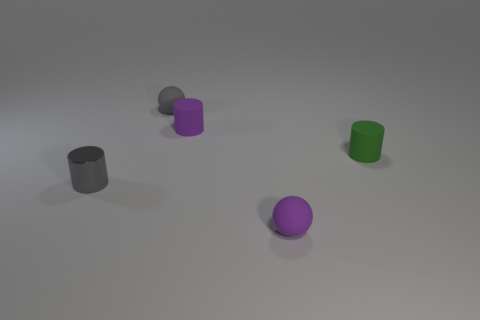Subtract 1 cylinders. How many cylinders are left? 2 Add 4 big yellow shiny cylinders. How many objects exist? 9 Subtract all cylinders. How many objects are left? 2 Add 2 green matte objects. How many green matte objects are left? 3 Add 4 small red objects. How many small red objects exist? 4 Subtract 0 yellow cubes. How many objects are left? 5 Subtract all small gray cylinders. Subtract all cylinders. How many objects are left? 1 